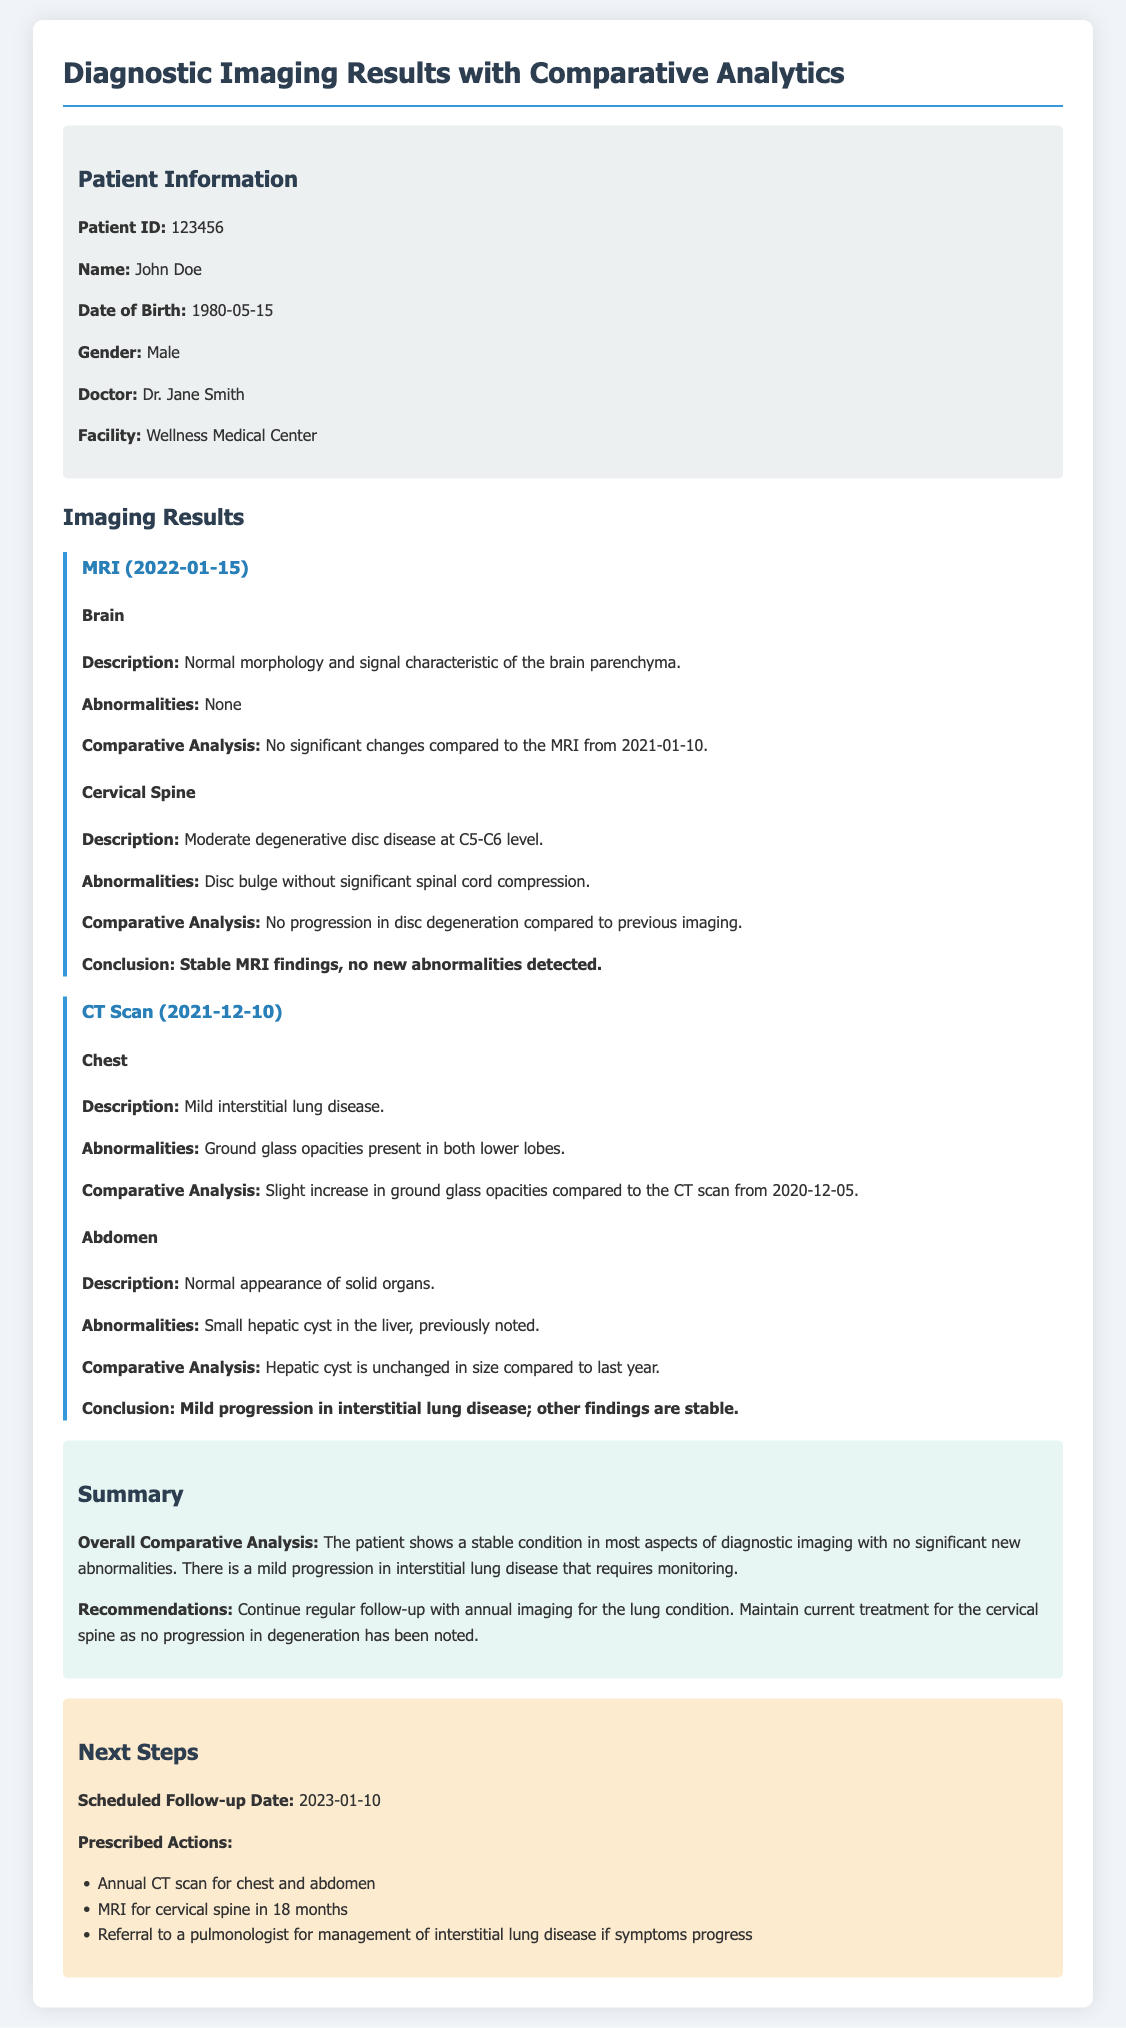What is the patient ID? The patient ID is a specific identifier for the patient registered in the document.
Answer: 123456 Who is the referring doctor? The referring doctor is mentioned in the patient information section of the document.
Answer: Dr. Jane Smith What imaging was performed on 2022-01-15? The type of imaging performed on that date is clearly specified under the imaging results.
Answer: MRI What finding was noted in the chest during the CT scan? The document details the findings in the chest section of the CT scan.
Answer: Mild interstitial lung disease What are the scheduled follow-up actions? The document outlines specific actions that are to be taken in the next steps section.
Answer: Annual CT scan for chest and abdomen What conclusion was drawn from the MRI results? The conclusion reflects the overall findings from the MRI subsection.
Answer: Stable MRI findings, no new abnormalities detected What type of abnormalities were found in the cervical spine? The document specifies the abnormalities related to the cervical spine imaging.
Answer: Disc bulge without significant spinal cord compression Is there any progression of the hepatic cyst? The comparative analysis for the abdomen section discusses the hepatic cyst's status over time.
Answer: Unchanged in size What year was the CT scan conducted before December 2021? The question requires referencing the date of the previous CT scan mentioned in the document.
Answer: 2020 